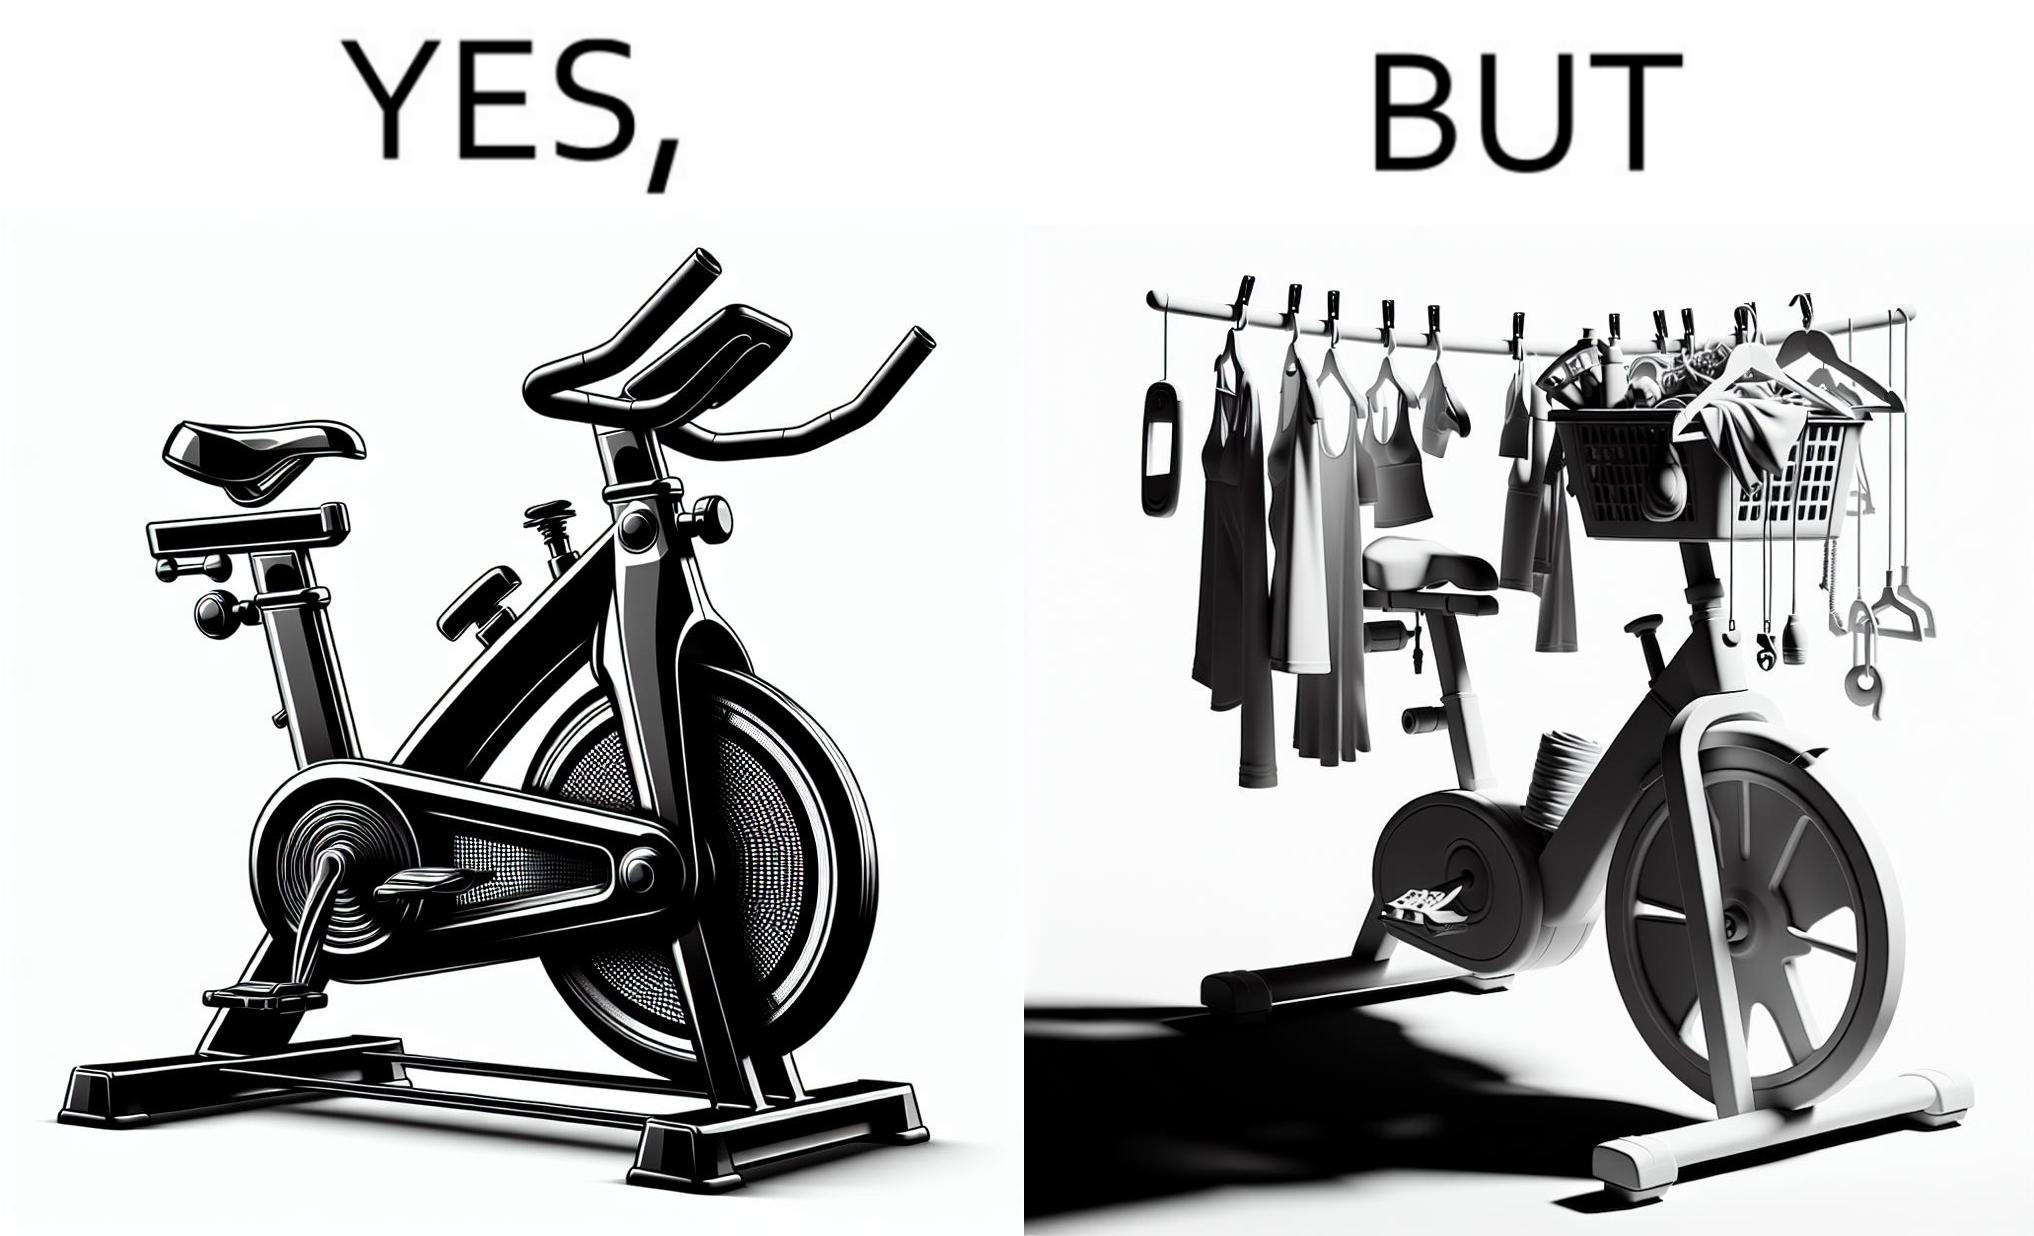Compare the left and right sides of this image. In the left part of the image: An exercise bike In the right part of the image: An exercise bike being used to hang clothes and other items 